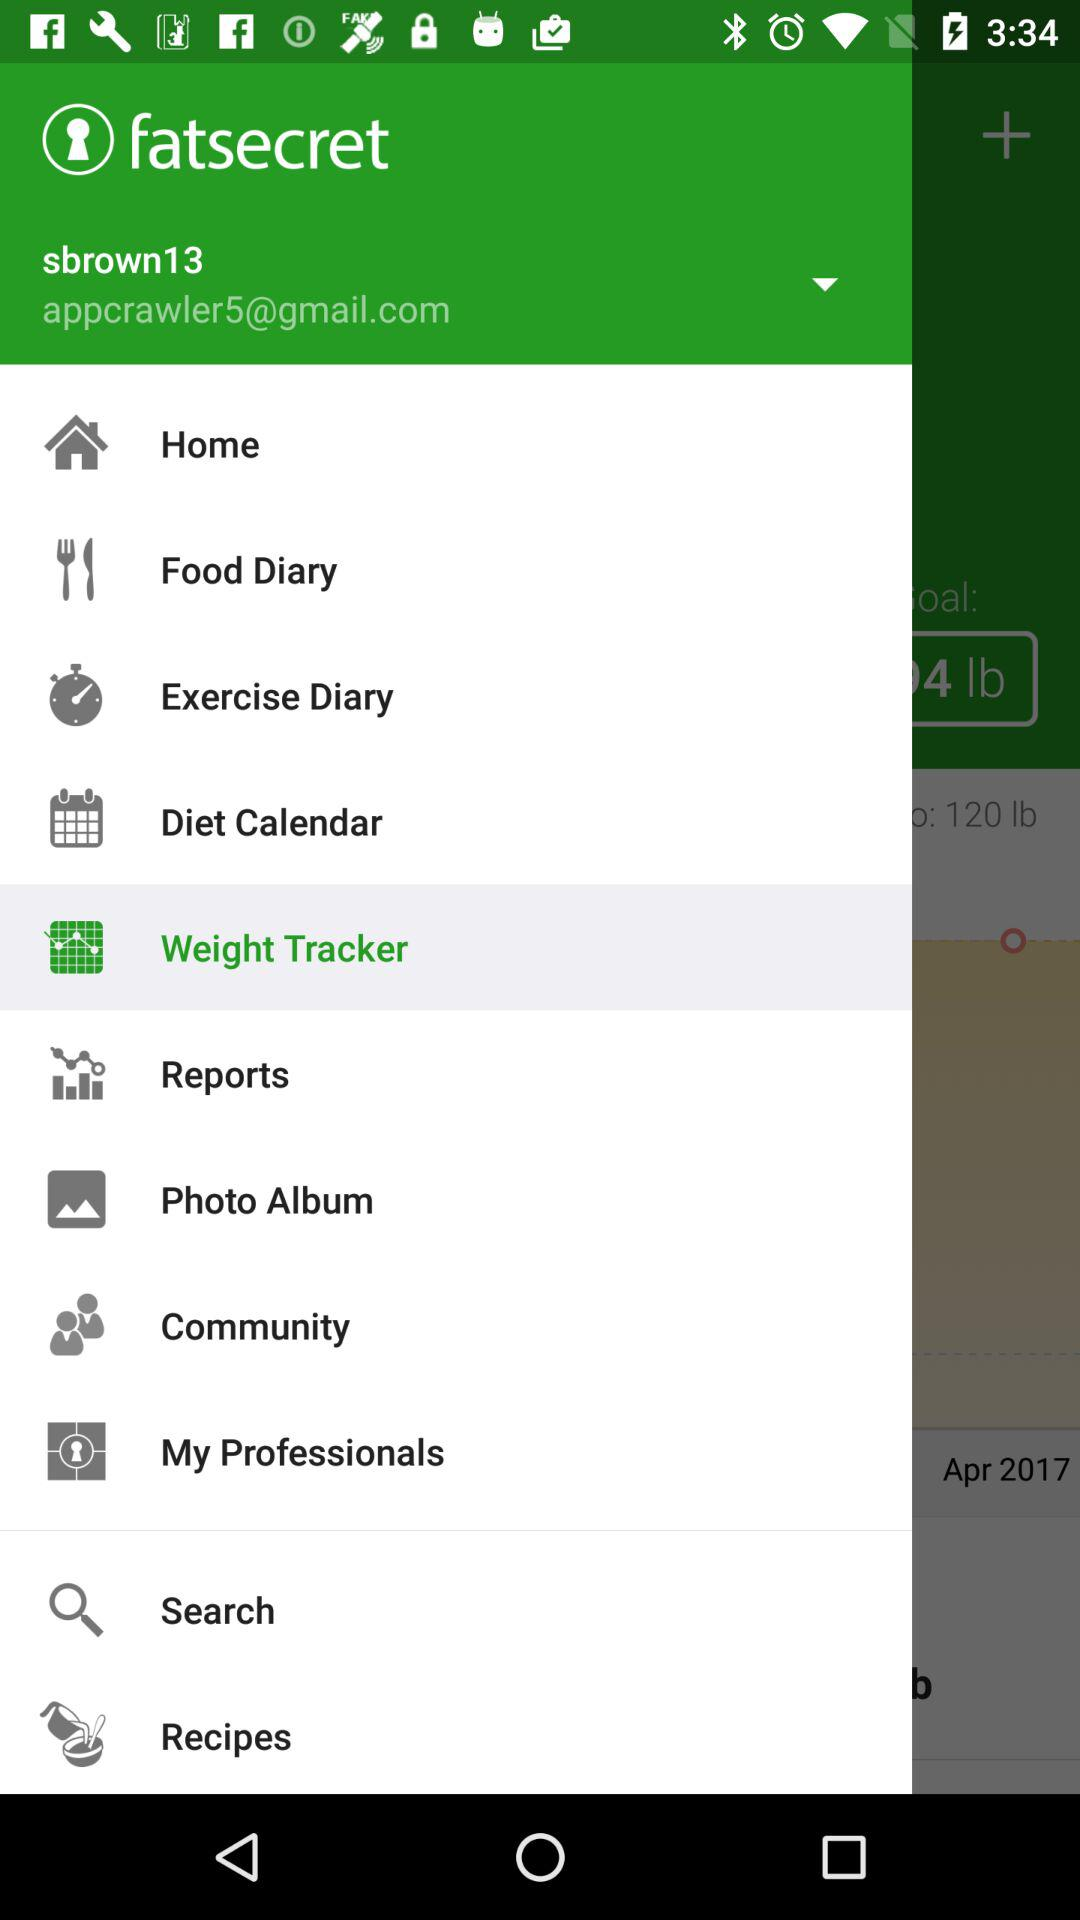What's the Google Mail address used by the user for the application? The Google Mail address used by the user for the application is appcrawler5@gmail.com. 